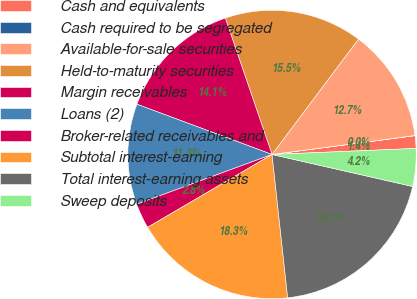<chart> <loc_0><loc_0><loc_500><loc_500><pie_chart><fcel>Cash and equivalents<fcel>Cash required to be segregated<fcel>Available-for-sale securities<fcel>Held-to-maturity securities<fcel>Margin receivables<fcel>Loans (2)<fcel>Broker-related receivables and<fcel>Subtotal interest-earning<fcel>Total interest-earning assets<fcel>Sweep deposits<nl><fcel>1.42%<fcel>0.01%<fcel>12.67%<fcel>15.49%<fcel>14.08%<fcel>11.27%<fcel>2.83%<fcel>18.3%<fcel>19.71%<fcel>4.23%<nl></chart> 